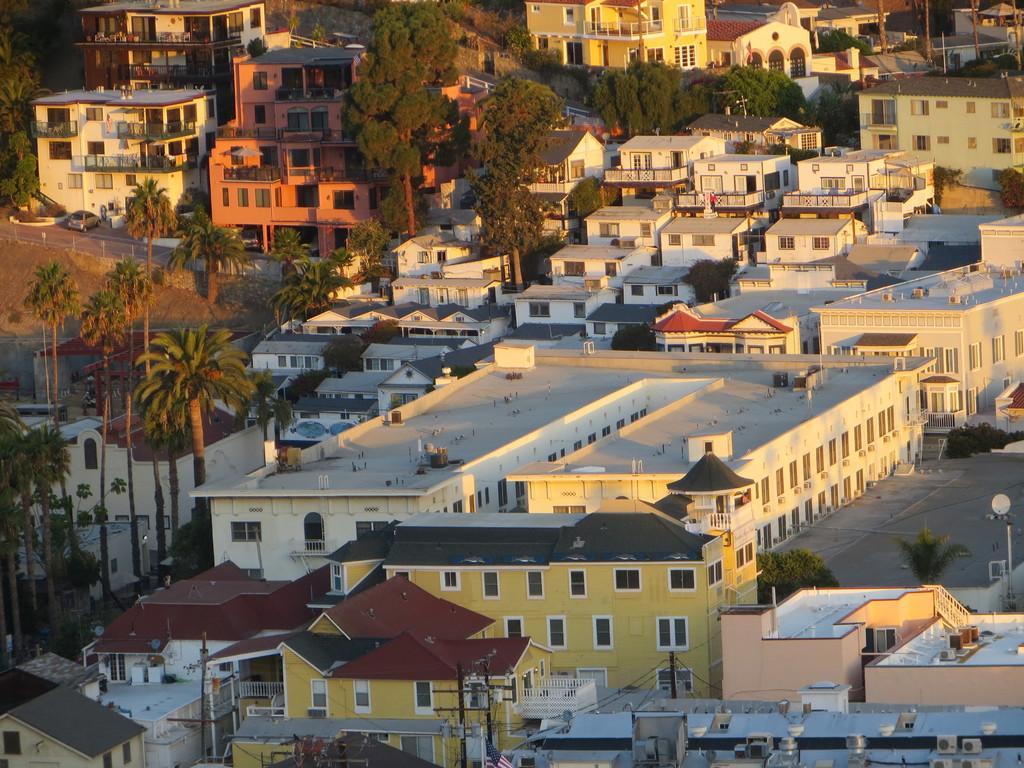How would you summarize this image in a sentence or two? In this picture we can see buildings, plants, poles, and trees. There is a car on the road. 